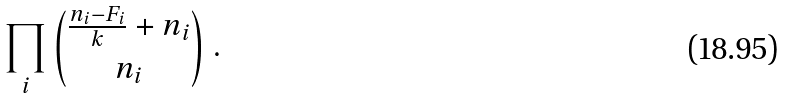<formula> <loc_0><loc_0><loc_500><loc_500>\prod _ { i } \binom { \frac { n _ { i } - F _ { i } } { k } + n _ { i } } { n _ { i } } \ .</formula> 